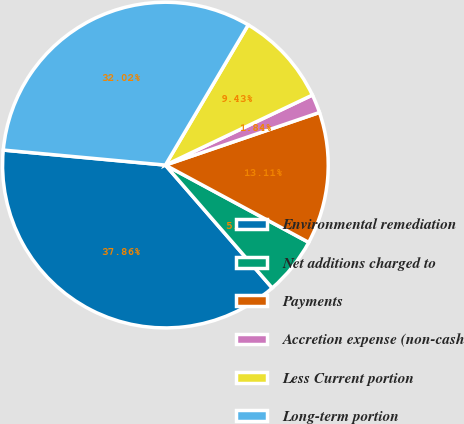<chart> <loc_0><loc_0><loc_500><loc_500><pie_chart><fcel>Environmental remediation<fcel>Net additions charged to<fcel>Payments<fcel>Accretion expense (non-cash<fcel>Less Current portion<fcel>Long-term portion<nl><fcel>37.86%<fcel>5.74%<fcel>13.11%<fcel>1.84%<fcel>9.43%<fcel>32.02%<nl></chart> 